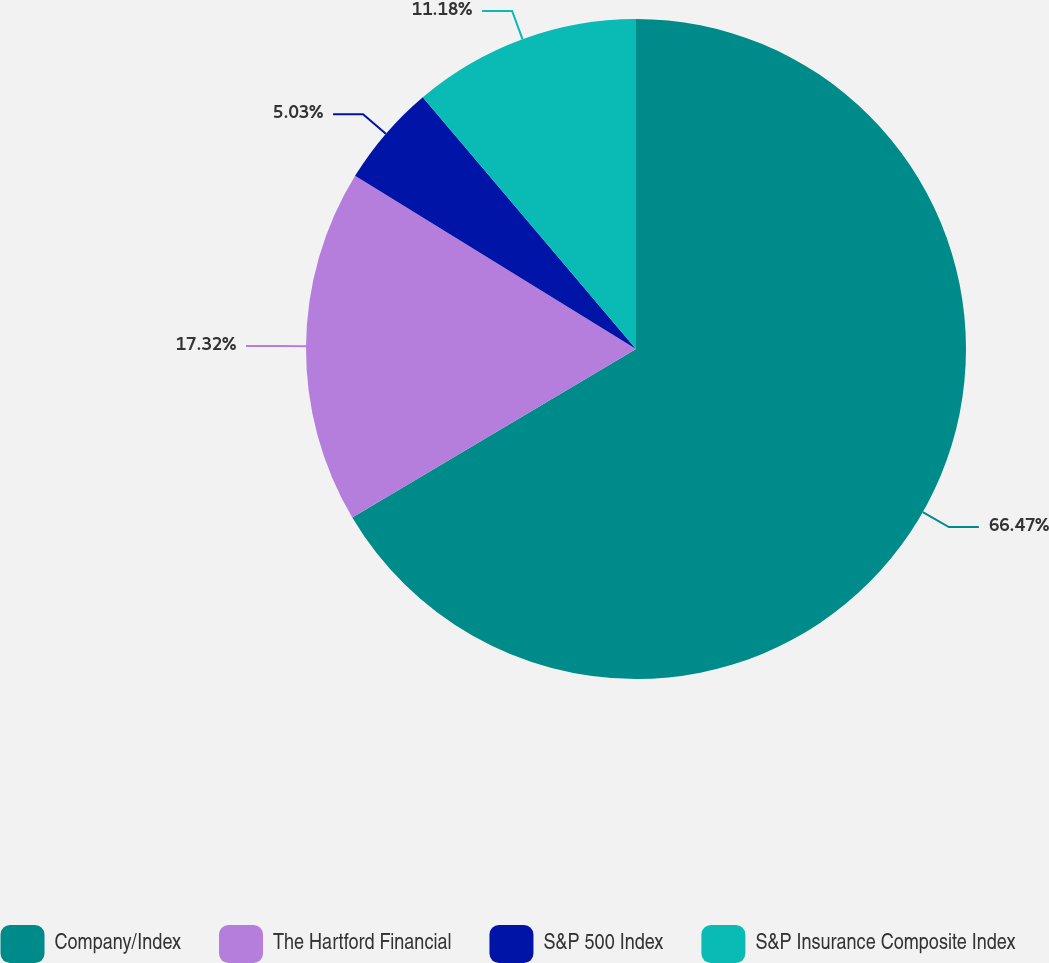Convert chart to OTSL. <chart><loc_0><loc_0><loc_500><loc_500><pie_chart><fcel>Company/Index<fcel>The Hartford Financial<fcel>S&P 500 Index<fcel>S&P Insurance Composite Index<nl><fcel>66.47%<fcel>17.32%<fcel>5.03%<fcel>11.18%<nl></chart> 